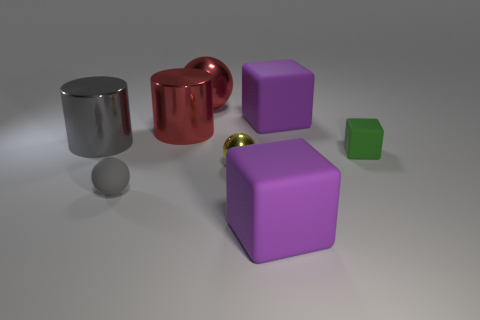Subtract all tiny spheres. How many spheres are left? 1 Subtract all green cubes. How many cubes are left? 2 Subtract 1 cylinders. How many cylinders are left? 1 Add 2 tiny red balls. How many objects exist? 10 Subtract all cylinders. How many objects are left? 6 Subtract all red blocks. How many purple spheres are left? 0 Add 4 tiny gray things. How many tiny gray things are left? 5 Add 8 metallic cylinders. How many metallic cylinders exist? 10 Subtract 0 cyan cylinders. How many objects are left? 8 Subtract all cyan blocks. Subtract all brown cylinders. How many blocks are left? 3 